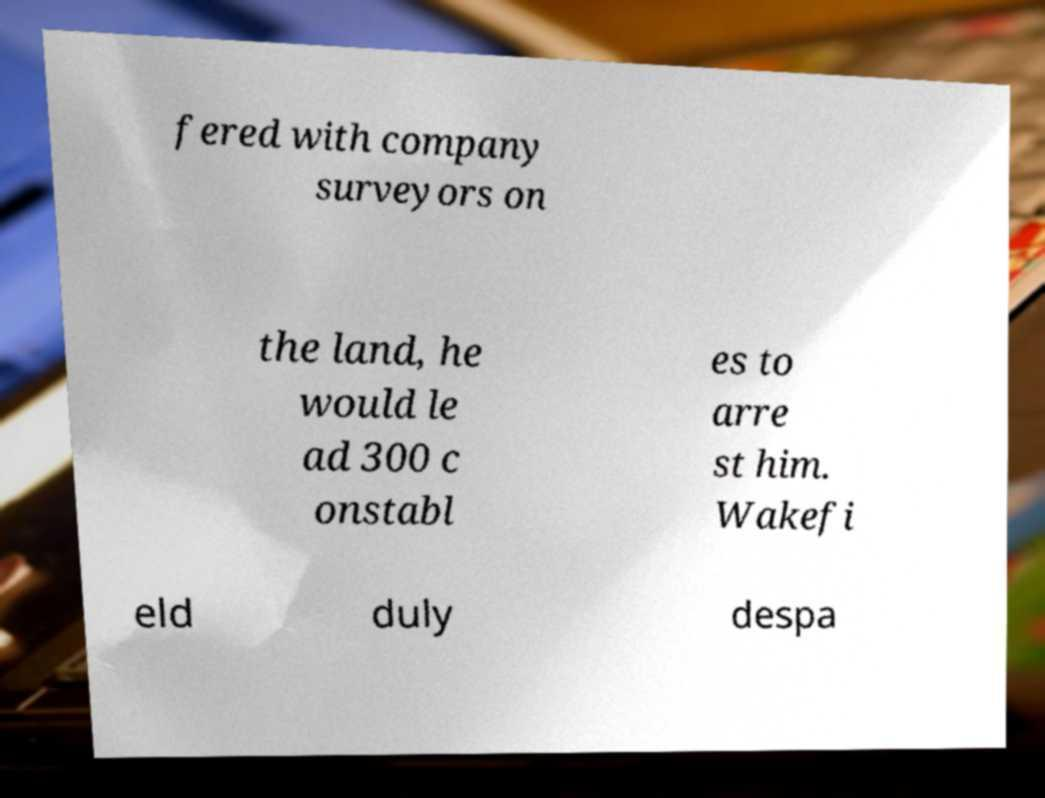What messages or text are displayed in this image? I need them in a readable, typed format. fered with company surveyors on the land, he would le ad 300 c onstabl es to arre st him. Wakefi eld duly despa 